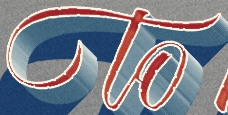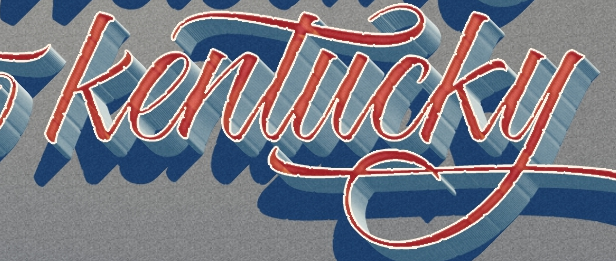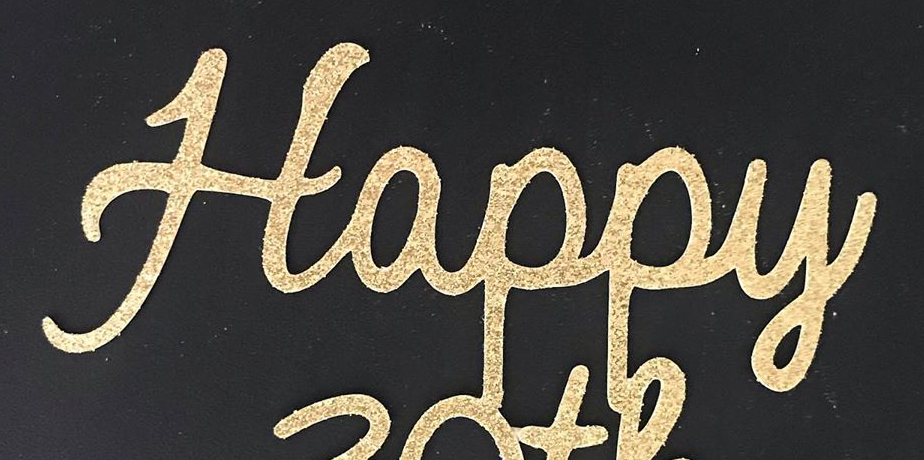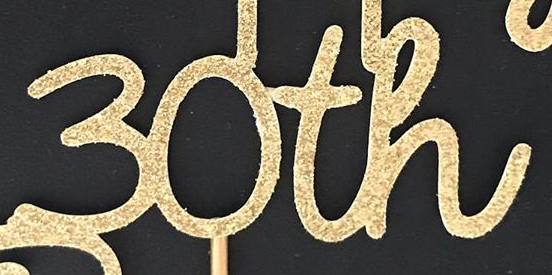What words can you see in these images in sequence, separated by a semicolon? to; kentucky; Happy; 30th 